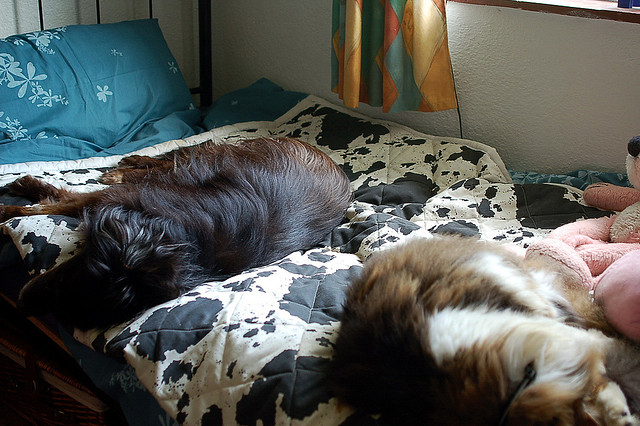Imagine if one of the dogs was named Bella and the other Max, how would you describe their personalities based on this image? Assuming the names, Bella seems to be the one lying closer to the camera, showing a relaxed yet attentive posture, potentially indicative of a gentle and observant personality. Max seems to be stretched out comfortably without a care in the world, suggesting a laid-back and content character. 